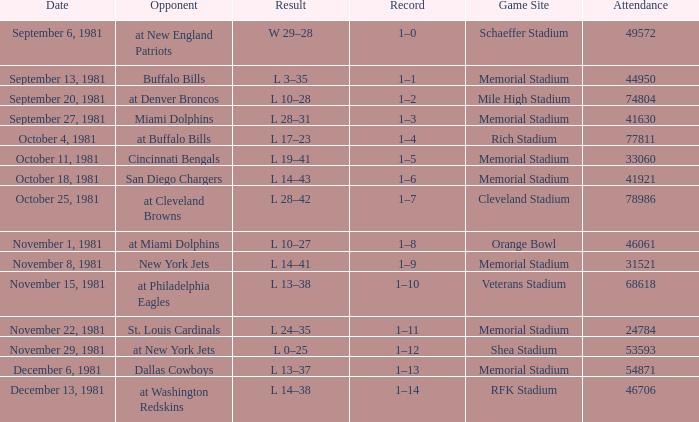During week 2, what is the performance? 1–1. 